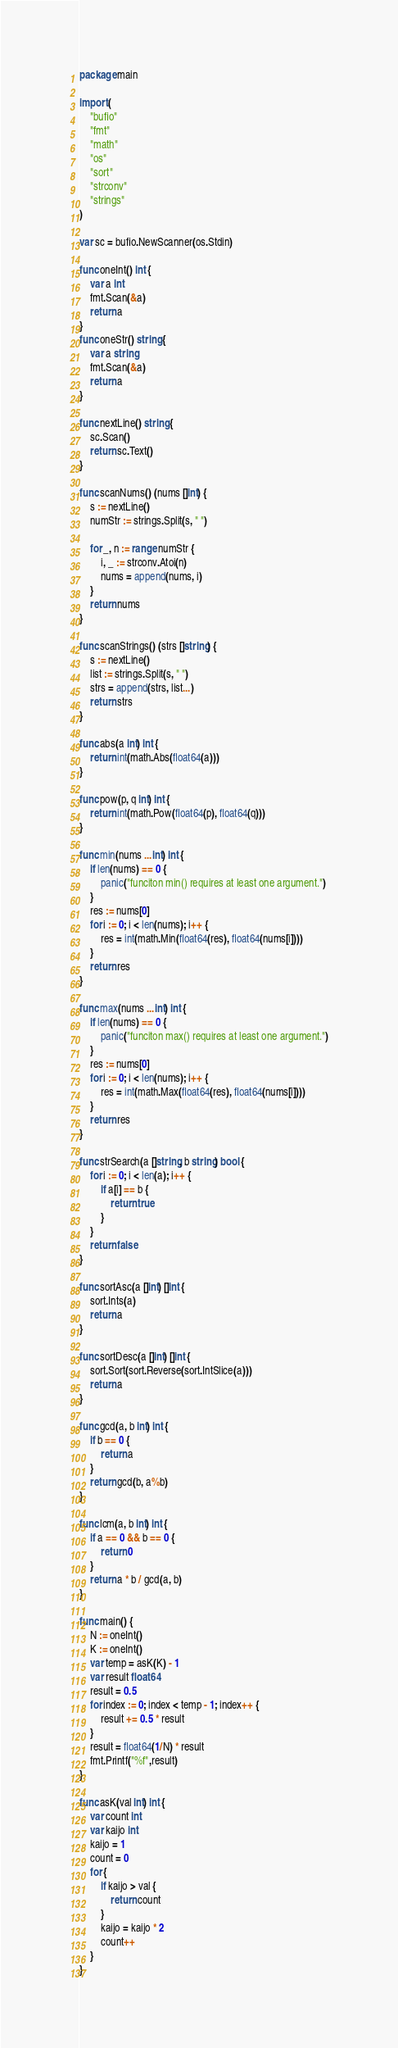<code> <loc_0><loc_0><loc_500><loc_500><_Go_>package main

import (
	"bufio"
	"fmt"
	"math"
	"os"
	"sort"
	"strconv"
	"strings"
)

var sc = bufio.NewScanner(os.Stdin)

func oneInt() int {
	var a int
	fmt.Scan(&a)
	return a
}
func oneStr() string {
	var a string
	fmt.Scan(&a)
	return a
}

func nextLine() string {
	sc.Scan()
	return sc.Text()
}

func scanNums() (nums []int) {
	s := nextLine()
	numStr := strings.Split(s, " ")

	for _, n := range numStr {
		i, _ := strconv.Atoi(n)
		nums = append(nums, i)
	}
	return nums
}

func scanStrings() (strs []string) {
	s := nextLine()
	list := strings.Split(s, " ")
	strs = append(strs, list...)
	return strs
}

func abs(a int) int {
	return int(math.Abs(float64(a)))
}

func pow(p, q int) int {
	return int(math.Pow(float64(p), float64(q)))
}

func min(nums ...int) int {
	if len(nums) == 0 {
		panic("funciton min() requires at least one argument.")
	}
	res := nums[0]
	for i := 0; i < len(nums); i++ {
		res = int(math.Min(float64(res), float64(nums[i])))
	}
	return res
}

func max(nums ...int) int {
	if len(nums) == 0 {
		panic("funciton max() requires at least one argument.")
	}
	res := nums[0]
	for i := 0; i < len(nums); i++ {
		res = int(math.Max(float64(res), float64(nums[i])))
	}
	return res
}

func strSearch(a []string, b string) bool {
	for i := 0; i < len(a); i++ {
		if a[i] == b {
			return true
		}
	}
	return false
}

func sortAsc(a []int) []int {
	sort.Ints(a)
	return a
}

func sortDesc(a []int) []int {
	sort.Sort(sort.Reverse(sort.IntSlice(a)))
	return a
}

func gcd(a, b int) int {
	if b == 0 {
		return a
	}
	return gcd(b, a%b)
}

func lcm(a, b int) int {
	if a == 0 && b == 0 {
		return 0
	}
	return a * b / gcd(a, b)
}

func main() {
	N := oneInt()
	K := oneInt()
	var temp = asK(K) - 1
	var result float64
	result = 0.5
	for index := 0; index < temp - 1; index++ {
		result += 0.5 * result
	}
	result = float64(1/N) * result
	fmt.Printf("%f",result)
}

func asK(val int) int {
	var count int
	var kaijo int
	kaijo = 1
	count = 0
	for {
		if kaijo > val {
			return count
		}
		kaijo = kaijo * 2
		count++
	}
}
</code> 